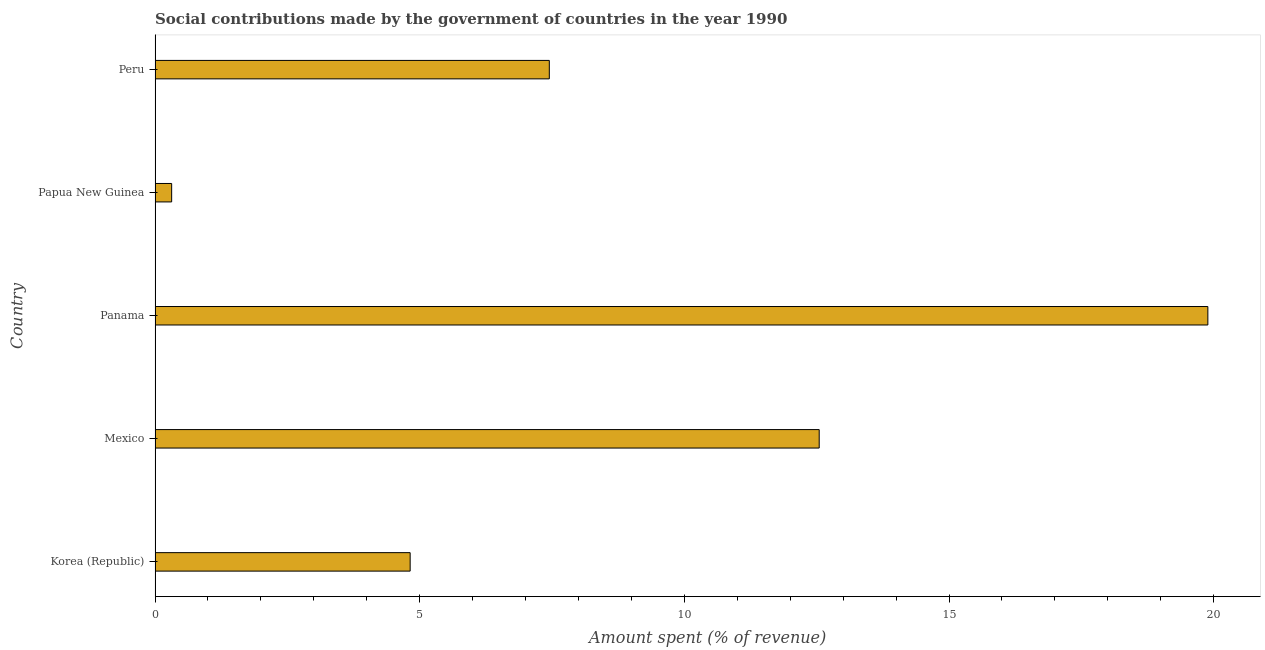Does the graph contain any zero values?
Offer a terse response. No. What is the title of the graph?
Provide a succinct answer. Social contributions made by the government of countries in the year 1990. What is the label or title of the X-axis?
Provide a succinct answer. Amount spent (% of revenue). What is the amount spent in making social contributions in Peru?
Offer a very short reply. 7.45. Across all countries, what is the maximum amount spent in making social contributions?
Your answer should be very brief. 19.89. Across all countries, what is the minimum amount spent in making social contributions?
Your response must be concise. 0.31. In which country was the amount spent in making social contributions maximum?
Your answer should be very brief. Panama. In which country was the amount spent in making social contributions minimum?
Provide a short and direct response. Papua New Guinea. What is the sum of the amount spent in making social contributions?
Provide a succinct answer. 45.02. What is the difference between the amount spent in making social contributions in Mexico and Papua New Guinea?
Ensure brevity in your answer.  12.23. What is the average amount spent in making social contributions per country?
Provide a succinct answer. 9. What is the median amount spent in making social contributions?
Your answer should be compact. 7.45. In how many countries, is the amount spent in making social contributions greater than 2 %?
Ensure brevity in your answer.  4. What is the ratio of the amount spent in making social contributions in Papua New Guinea to that in Peru?
Your answer should be very brief. 0.04. Is the amount spent in making social contributions in Panama less than that in Peru?
Your answer should be very brief. No. What is the difference between the highest and the second highest amount spent in making social contributions?
Your answer should be compact. 7.34. Is the sum of the amount spent in making social contributions in Panama and Peru greater than the maximum amount spent in making social contributions across all countries?
Your answer should be compact. Yes. What is the difference between the highest and the lowest amount spent in making social contributions?
Offer a very short reply. 19.58. In how many countries, is the amount spent in making social contributions greater than the average amount spent in making social contributions taken over all countries?
Offer a very short reply. 2. How many bars are there?
Offer a terse response. 5. How many countries are there in the graph?
Your answer should be compact. 5. What is the Amount spent (% of revenue) in Korea (Republic)?
Provide a succinct answer. 4.82. What is the Amount spent (% of revenue) in Mexico?
Ensure brevity in your answer.  12.55. What is the Amount spent (% of revenue) in Panama?
Offer a very short reply. 19.89. What is the Amount spent (% of revenue) of Papua New Guinea?
Your response must be concise. 0.31. What is the Amount spent (% of revenue) of Peru?
Offer a very short reply. 7.45. What is the difference between the Amount spent (% of revenue) in Korea (Republic) and Mexico?
Keep it short and to the point. -7.73. What is the difference between the Amount spent (% of revenue) in Korea (Republic) and Panama?
Provide a succinct answer. -15.07. What is the difference between the Amount spent (% of revenue) in Korea (Republic) and Papua New Guinea?
Give a very brief answer. 4.51. What is the difference between the Amount spent (% of revenue) in Korea (Republic) and Peru?
Ensure brevity in your answer.  -2.63. What is the difference between the Amount spent (% of revenue) in Mexico and Panama?
Provide a short and direct response. -7.34. What is the difference between the Amount spent (% of revenue) in Mexico and Papua New Guinea?
Offer a terse response. 12.23. What is the difference between the Amount spent (% of revenue) in Mexico and Peru?
Give a very brief answer. 5.1. What is the difference between the Amount spent (% of revenue) in Panama and Papua New Guinea?
Your answer should be very brief. 19.58. What is the difference between the Amount spent (% of revenue) in Panama and Peru?
Offer a terse response. 12.44. What is the difference between the Amount spent (% of revenue) in Papua New Guinea and Peru?
Offer a very short reply. -7.13. What is the ratio of the Amount spent (% of revenue) in Korea (Republic) to that in Mexico?
Keep it short and to the point. 0.38. What is the ratio of the Amount spent (% of revenue) in Korea (Republic) to that in Panama?
Keep it short and to the point. 0.24. What is the ratio of the Amount spent (% of revenue) in Korea (Republic) to that in Papua New Guinea?
Offer a terse response. 15.38. What is the ratio of the Amount spent (% of revenue) in Korea (Republic) to that in Peru?
Ensure brevity in your answer.  0.65. What is the ratio of the Amount spent (% of revenue) in Mexico to that in Panama?
Your answer should be compact. 0.63. What is the ratio of the Amount spent (% of revenue) in Mexico to that in Papua New Guinea?
Ensure brevity in your answer.  40.03. What is the ratio of the Amount spent (% of revenue) in Mexico to that in Peru?
Give a very brief answer. 1.69. What is the ratio of the Amount spent (% of revenue) in Panama to that in Papua New Guinea?
Your answer should be compact. 63.45. What is the ratio of the Amount spent (% of revenue) in Panama to that in Peru?
Keep it short and to the point. 2.67. What is the ratio of the Amount spent (% of revenue) in Papua New Guinea to that in Peru?
Give a very brief answer. 0.04. 